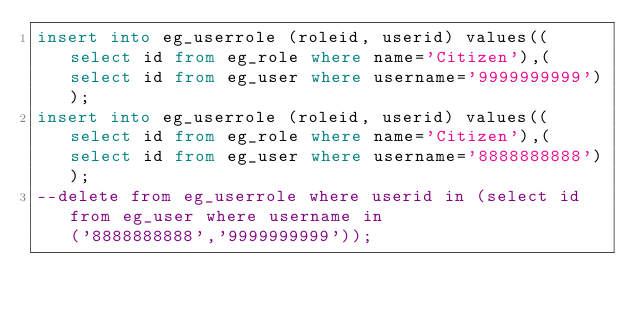Convert code to text. <code><loc_0><loc_0><loc_500><loc_500><_SQL_>insert into eg_userrole (roleid, userid) values((select id from eg_role where name='Citizen'),(select id from eg_user where username='9999999999'));
insert into eg_userrole (roleid, userid) values((select id from eg_role where name='Citizen'),(select id from eg_user where username='8888888888'));
--delete from eg_userrole where userid in (select id from eg_user where username in ('8888888888','9999999999'));
</code> 